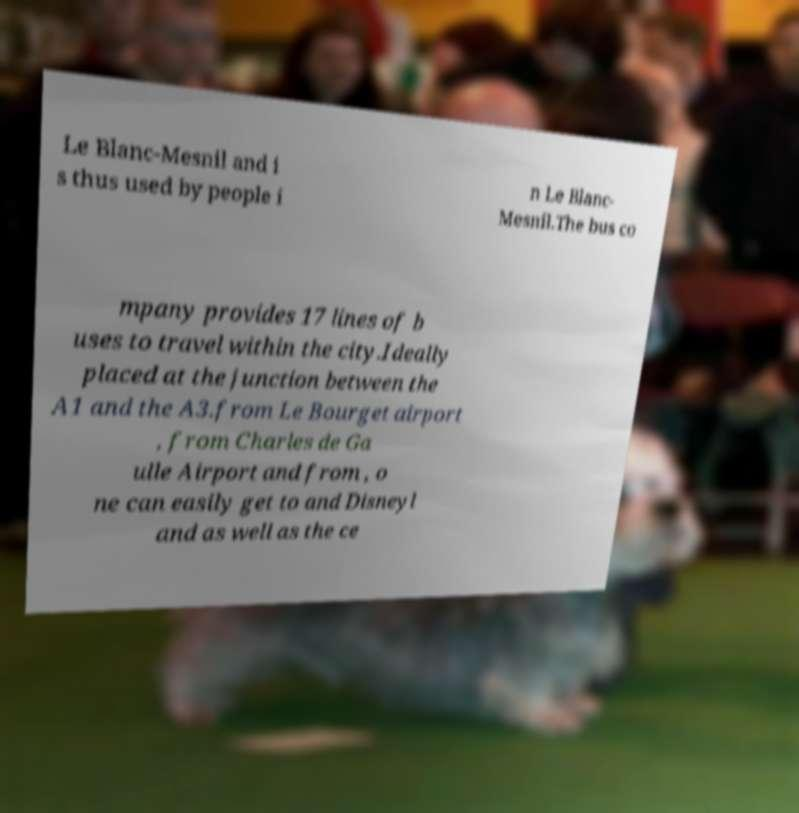Can you read and provide the text displayed in the image?This photo seems to have some interesting text. Can you extract and type it out for me? Le Blanc-Mesnil and i s thus used by people i n Le Blanc- Mesnil.The bus co mpany provides 17 lines of b uses to travel within the city.Ideally placed at the junction between the A1 and the A3.from Le Bourget airport , from Charles de Ga ulle Airport and from , o ne can easily get to and Disneyl and as well as the ce 